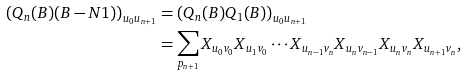<formula> <loc_0><loc_0><loc_500><loc_500>\left ( Q _ { n } ( B ) ( B - N 1 ) \right ) _ { u _ { 0 } u _ { n + 1 } } & = \left ( Q _ { n } ( B ) Q _ { 1 } ( B ) \right ) _ { u _ { 0 } u _ { n + 1 } } \\ & = \sum _ { p _ { n + 1 } } X _ { u _ { 0 } v _ { 0 } } X _ { u _ { 1 } v _ { 0 } } \cdots X _ { u _ { n - 1 } v _ { n } } X _ { u _ { n } v _ { n - 1 } } X _ { u _ { n } v _ { n } } X _ { u _ { n + 1 } v _ { n } } ,</formula> 